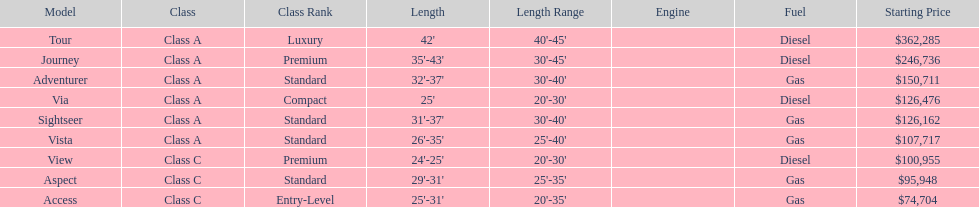How long is the aspect? 29'-31'. 